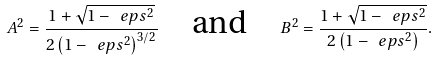<formula> <loc_0><loc_0><loc_500><loc_500>A ^ { 2 } = \frac { 1 + \sqrt { 1 - \ e p s ^ { 2 } } } { 2 \left ( 1 - \ e p s ^ { 2 } \right ) ^ { 3 / 2 } } \quad \text {and} \quad B ^ { 2 } = \frac { 1 + \sqrt { 1 - \ e p s ^ { 2 } } } { 2 \left ( 1 - \ e p s ^ { 2 } \right ) } .</formula> 